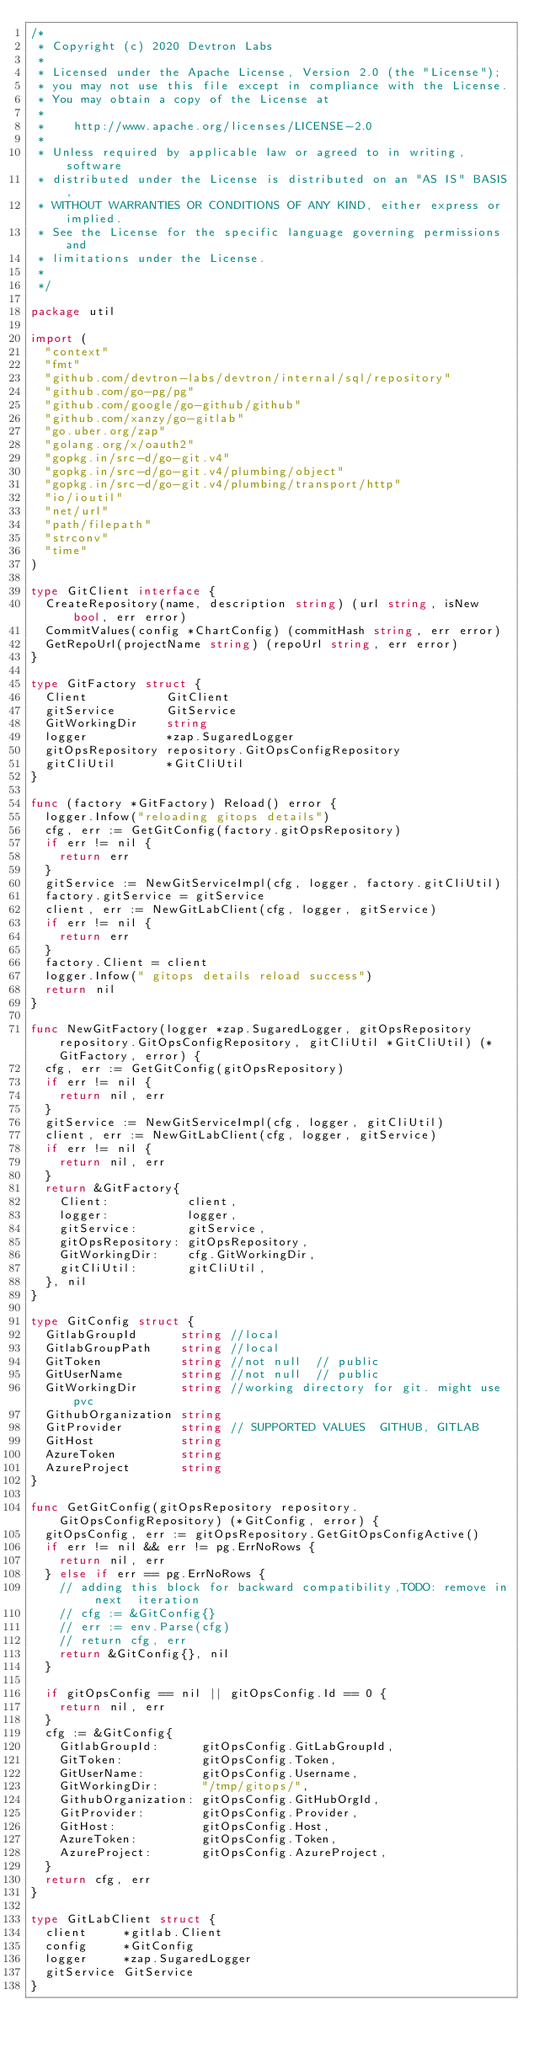Convert code to text. <code><loc_0><loc_0><loc_500><loc_500><_Go_>/*
 * Copyright (c) 2020 Devtron Labs
 *
 * Licensed under the Apache License, Version 2.0 (the "License");
 * you may not use this file except in compliance with the License.
 * You may obtain a copy of the License at
 *
 *    http://www.apache.org/licenses/LICENSE-2.0
 *
 * Unless required by applicable law or agreed to in writing, software
 * distributed under the License is distributed on an "AS IS" BASIS,
 * WITHOUT WARRANTIES OR CONDITIONS OF ANY KIND, either express or implied.
 * See the License for the specific language governing permissions and
 * limitations under the License.
 *
 */

package util

import (
	"context"
	"fmt"
	"github.com/devtron-labs/devtron/internal/sql/repository"
	"github.com/go-pg/pg"
	"github.com/google/go-github/github"
	"github.com/xanzy/go-gitlab"
	"go.uber.org/zap"
	"golang.org/x/oauth2"
	"gopkg.in/src-d/go-git.v4"
	"gopkg.in/src-d/go-git.v4/plumbing/object"
	"gopkg.in/src-d/go-git.v4/plumbing/transport/http"
	"io/ioutil"
	"net/url"
	"path/filepath"
	"strconv"
	"time"
)

type GitClient interface {
	CreateRepository(name, description string) (url string, isNew bool, err error)
	CommitValues(config *ChartConfig) (commitHash string, err error)
	GetRepoUrl(projectName string) (repoUrl string, err error)
}

type GitFactory struct {
	Client           GitClient
	gitService       GitService
	GitWorkingDir    string
	logger           *zap.SugaredLogger
	gitOpsRepository repository.GitOpsConfigRepository
	gitCliUtil       *GitCliUtil
}

func (factory *GitFactory) Reload() error {
	logger.Infow("reloading gitops details")
	cfg, err := GetGitConfig(factory.gitOpsRepository)
	if err != nil {
		return err
	}
	gitService := NewGitServiceImpl(cfg, logger, factory.gitCliUtil)
	factory.gitService = gitService
	client, err := NewGitLabClient(cfg, logger, gitService)
	if err != nil {
		return err
	}
	factory.Client = client
	logger.Infow(" gitops details reload success")
	return nil
}

func NewGitFactory(logger *zap.SugaredLogger, gitOpsRepository repository.GitOpsConfigRepository, gitCliUtil *GitCliUtil) (*GitFactory, error) {
	cfg, err := GetGitConfig(gitOpsRepository)
	if err != nil {
		return nil, err
	}
	gitService := NewGitServiceImpl(cfg, logger, gitCliUtil)
	client, err := NewGitLabClient(cfg, logger, gitService)
	if err != nil {
		return nil, err
	}
	return &GitFactory{
		Client:           client,
		logger:           logger,
		gitService:       gitService,
		gitOpsRepository: gitOpsRepository,
		GitWorkingDir:    cfg.GitWorkingDir,
		gitCliUtil:       gitCliUtil,
	}, nil
}

type GitConfig struct {
	GitlabGroupId      string //local
	GitlabGroupPath    string //local
	GitToken           string //not null  // public
	GitUserName        string //not null  // public
	GitWorkingDir      string //working directory for git. might use pvc
	GithubOrganization string
	GitProvider        string // SUPPORTED VALUES  GITHUB, GITLAB
	GitHost            string
	AzureToken         string
	AzureProject       string
}

func GetGitConfig(gitOpsRepository repository.GitOpsConfigRepository) (*GitConfig, error) {
	gitOpsConfig, err := gitOpsRepository.GetGitOpsConfigActive()
	if err != nil && err != pg.ErrNoRows {
		return nil, err
	} else if err == pg.ErrNoRows {
		// adding this block for backward compatibility,TODO: remove in next  iteration
		// cfg := &GitConfig{}
		// err := env.Parse(cfg)
		// return cfg, err
		return &GitConfig{}, nil
	}

	if gitOpsConfig == nil || gitOpsConfig.Id == 0 {
		return nil, err
	}
	cfg := &GitConfig{
		GitlabGroupId:      gitOpsConfig.GitLabGroupId,
		GitToken:           gitOpsConfig.Token,
		GitUserName:        gitOpsConfig.Username,
		GitWorkingDir:      "/tmp/gitops/",
		GithubOrganization: gitOpsConfig.GitHubOrgId,
		GitProvider:        gitOpsConfig.Provider,
		GitHost:            gitOpsConfig.Host,
		AzureToken:         gitOpsConfig.Token,
		AzureProject:       gitOpsConfig.AzureProject,
	}
	return cfg, err
}

type GitLabClient struct {
	client     *gitlab.Client
	config     *GitConfig
	logger     *zap.SugaredLogger
	gitService GitService
}
</code> 